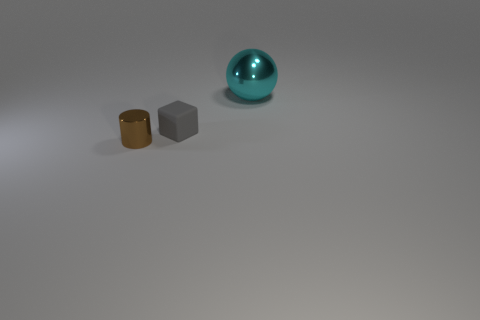Is there any other thing that has the same size as the cyan sphere?
Offer a terse response. No. What number of gray matte things are there?
Make the answer very short. 1. Does the object on the right side of the tiny cube have the same material as the tiny brown object?
Provide a short and direct response. Yes. Is there another cyan thing of the same size as the cyan shiny thing?
Your response must be concise. No. Is the shape of the small gray object the same as the metal object to the left of the cyan metal sphere?
Provide a succinct answer. No. Are there any large things on the left side of the small object that is behind the shiny thing in front of the large cyan shiny sphere?
Offer a very short reply. No. What is the size of the metallic sphere?
Your answer should be compact. Large. What number of other things are there of the same color as the shiny ball?
Your answer should be compact. 0. Do the thing in front of the tiny gray rubber cube and the gray rubber object have the same shape?
Ensure brevity in your answer.  No. Are there any other things that have the same material as the small gray block?
Keep it short and to the point. No. 